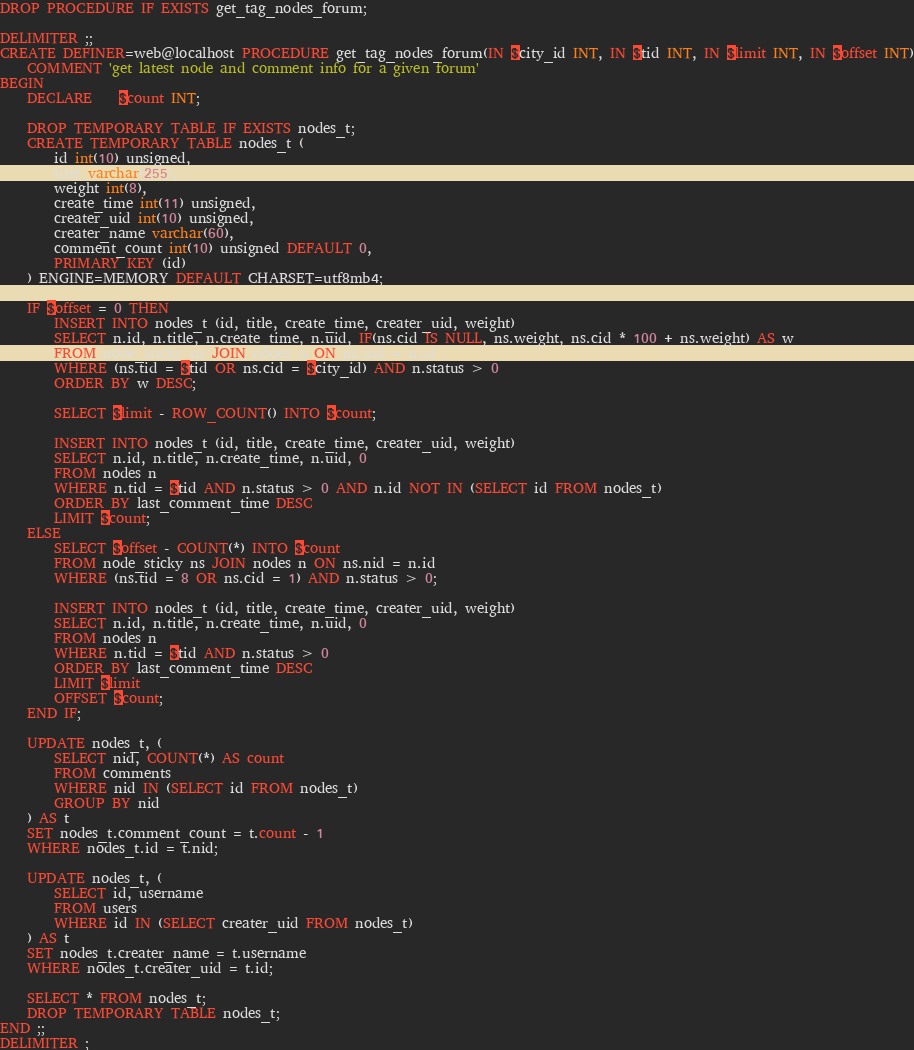<code> <loc_0><loc_0><loc_500><loc_500><_SQL_>DROP PROCEDURE IF EXISTS get_tag_nodes_forum;

DELIMITER ;;
CREATE DEFINER=web@localhost PROCEDURE get_tag_nodes_forum(IN $city_id INT, IN $tid INT, IN $limit INT, IN $offset INT)
    COMMENT 'get latest node and comment info for a given forum'
BEGIN
    DECLARE    $count INT;

    DROP TEMPORARY TABLE IF EXISTS nodes_t;
    CREATE TEMPORARY TABLE nodes_t (
        id int(10) unsigned,
        title varchar(255),
        weight int(8),
        create_time int(11) unsigned,
        creater_uid int(10) unsigned,
        creater_name varchar(60),
        comment_count int(10) unsigned DEFAULT 0,
        PRIMARY KEY (id)
    ) ENGINE=MEMORY DEFAULT CHARSET=utf8mb4;

    IF $offset = 0 THEN
        INSERT INTO nodes_t (id, title, create_time, creater_uid, weight)
        SELECT n.id, n.title, n.create_time, n.uid, IF(ns.cid IS NULL, ns.weight, ns.cid * 100 + ns.weight) AS w
        FROM node_sticky ns JOIN nodes n ON ns.nid = n.id
        WHERE (ns.tid = $tid OR ns.cid = $city_id) AND n.status > 0
        ORDER BY w DESC;

        SELECT $limit - ROW_COUNT() INTO $count;

        INSERT INTO nodes_t (id, title, create_time, creater_uid, weight)
        SELECT n.id, n.title, n.create_time, n.uid, 0
        FROM nodes n
        WHERE n.tid = $tid AND n.status > 0 AND n.id NOT IN (SELECT id FROM nodes_t)
        ORDER BY last_comment_time DESC
        LIMIT $count;
    ELSE
        SELECT $offset - COUNT(*) INTO $count
        FROM node_sticky ns JOIN nodes n ON ns.nid = n.id
        WHERE (ns.tid = 8 OR ns.cid = 1) AND n.status > 0;

        INSERT INTO nodes_t (id, title, create_time, creater_uid, weight)
        SELECT n.id, n.title, n.create_time, n.uid, 0
        FROM nodes n
        WHERE n.tid = $tid AND n.status > 0
        ORDER BY last_comment_time DESC
        LIMIT $limit
        OFFSET $count;
    END IF;

    UPDATE nodes_t, (
        SELECT nid, COUNT(*) AS count
        FROM comments
        WHERE nid IN (SELECT id FROM nodes_t)
        GROUP BY nid
    ) AS t
    SET nodes_t.comment_count = t.count - 1
    WHERE nodes_t.id = t.nid;

    UPDATE nodes_t, (
        SELECT id, username
        FROM users
        WHERE id IN (SELECT creater_uid FROM nodes_t)
    ) AS t
    SET nodes_t.creater_name = t.username
    WHERE nodes_t.creater_uid = t.id;

    SELECT * FROM nodes_t;
    DROP TEMPORARY TABLE nodes_t;
END ;;
DELIMITER ;
</code> 